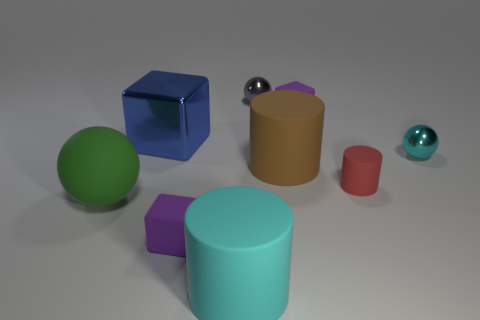What number of purple rubber objects have the same size as the cyan metallic ball?
Your response must be concise. 2. How many red objects are either big balls or shiny things?
Keep it short and to the point. 0. Are there the same number of big brown cylinders in front of the cyan cylinder and small red metal things?
Provide a short and direct response. Yes. There is a sphere that is left of the small gray shiny sphere; what size is it?
Your answer should be compact. Large. What number of big cyan things are the same shape as the red thing?
Offer a very short reply. 1. There is a tiny thing that is in front of the big cube and behind the red object; what is its material?
Offer a terse response. Metal. Is the material of the brown cylinder the same as the big green ball?
Make the answer very short. Yes. How many tiny red metallic cubes are there?
Provide a succinct answer. 0. There is a thing that is in front of the small matte cube that is left of the tiny gray metallic object behind the shiny cube; what color is it?
Your answer should be very brief. Cyan. How many big things are both in front of the red rubber thing and behind the large cyan cylinder?
Provide a succinct answer. 1. 